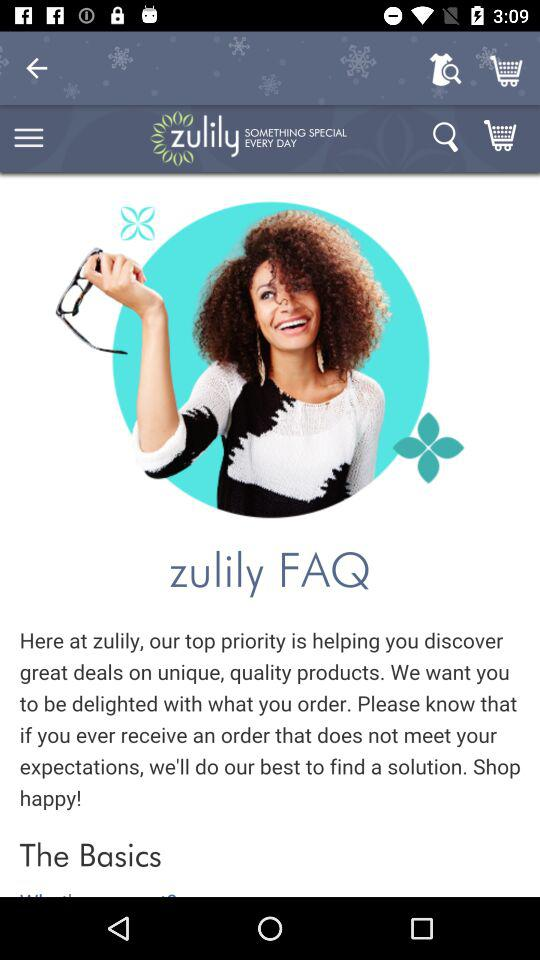What is the application name? The application name is "zulily". 